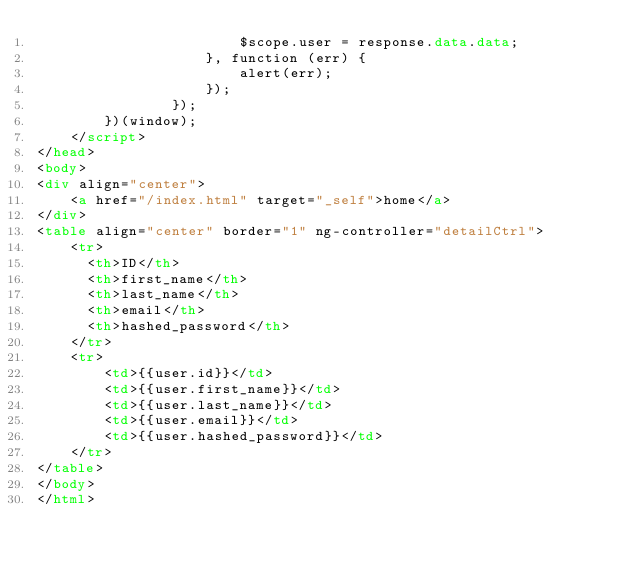Convert code to text. <code><loc_0><loc_0><loc_500><loc_500><_HTML_>                        $scope.user = response.data.data;
                    }, function (err) {
                        alert(err);
                    });
                });
        })(window);
    </script>
</head>
<body>
<div align="center">
    <a href="/index.html" target="_self">home</a>
</div>
<table align="center" border="1" ng-controller="detailCtrl">
    <tr>
      <th>ID</th>
      <th>first_name</th>
      <th>last_name</th>
      <th>email</th>
      <th>hashed_password</th>
    </tr>
    <tr>
        <td>{{user.id}}</td>
        <td>{{user.first_name}}</td>
        <td>{{user.last_name}}</td>
        <td>{{user.email}}</td>
        <td>{{user.hashed_password}}</td>
    </tr>
</table>
</body>
</html>
</code> 